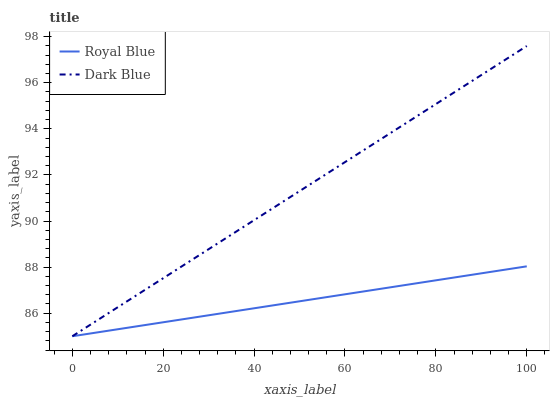Does Royal Blue have the minimum area under the curve?
Answer yes or no. Yes. Does Dark Blue have the maximum area under the curve?
Answer yes or no. Yes. Does Dark Blue have the minimum area under the curve?
Answer yes or no. No. Is Royal Blue the smoothest?
Answer yes or no. Yes. Is Dark Blue the roughest?
Answer yes or no. Yes. Is Dark Blue the smoothest?
Answer yes or no. No. Does Royal Blue have the lowest value?
Answer yes or no. Yes. Does Dark Blue have the highest value?
Answer yes or no. Yes. Does Royal Blue intersect Dark Blue?
Answer yes or no. Yes. Is Royal Blue less than Dark Blue?
Answer yes or no. No. Is Royal Blue greater than Dark Blue?
Answer yes or no. No. 